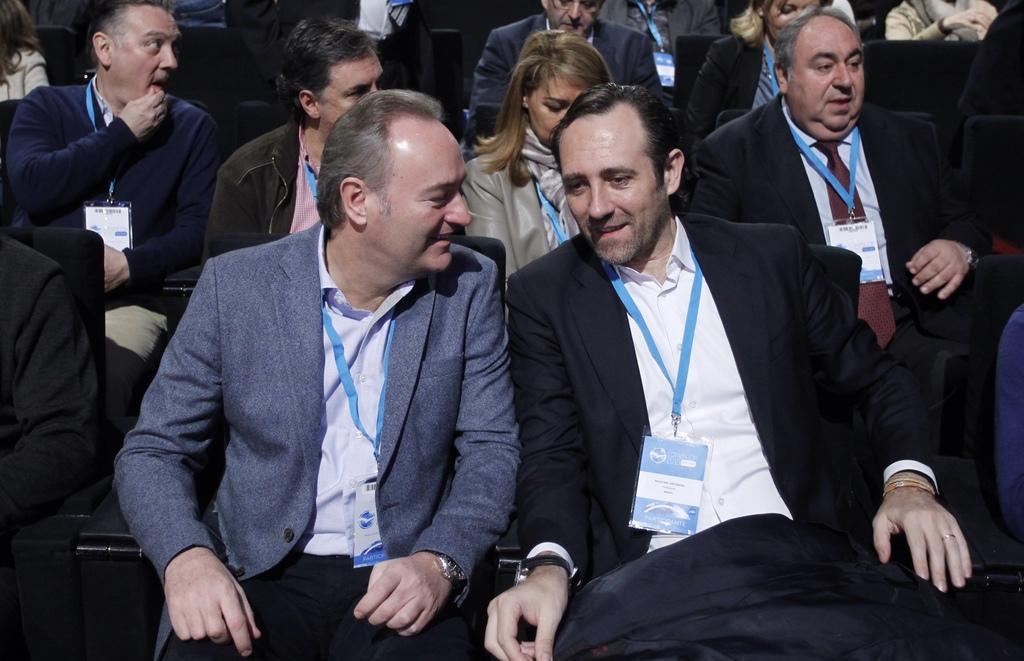Could you give a brief overview of what you see in this image? In this image I can see the group of people with different color dresses. I can see these people with the identification cards and they are sitting on the chairs. 